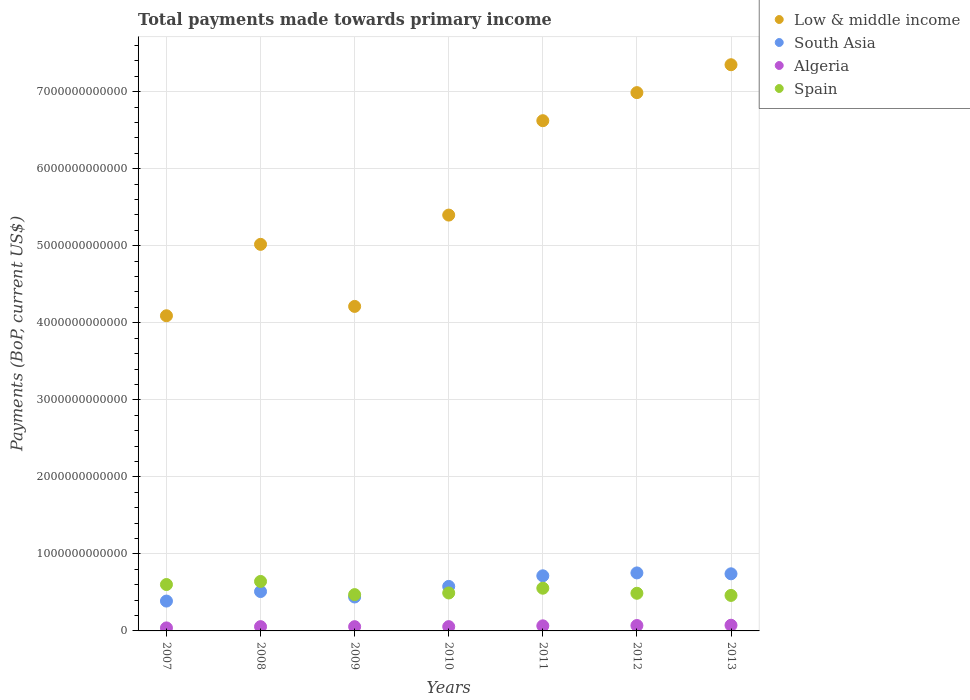What is the total payments made towards primary income in Spain in 2007?
Provide a succinct answer. 6.02e+11. Across all years, what is the maximum total payments made towards primary income in Low & middle income?
Your response must be concise. 7.35e+12. Across all years, what is the minimum total payments made towards primary income in Low & middle income?
Keep it short and to the point. 4.09e+12. In which year was the total payments made towards primary income in South Asia maximum?
Provide a succinct answer. 2012. What is the total total payments made towards primary income in Spain in the graph?
Provide a short and direct response. 3.71e+12. What is the difference between the total payments made towards primary income in Spain in 2009 and that in 2011?
Provide a short and direct response. -8.31e+1. What is the difference between the total payments made towards primary income in South Asia in 2011 and the total payments made towards primary income in Algeria in 2012?
Keep it short and to the point. 6.45e+11. What is the average total payments made towards primary income in Low & middle income per year?
Give a very brief answer. 5.67e+12. In the year 2011, what is the difference between the total payments made towards primary income in Spain and total payments made towards primary income in Low & middle income?
Keep it short and to the point. -6.07e+12. What is the ratio of the total payments made towards primary income in Low & middle income in 2008 to that in 2010?
Offer a very short reply. 0.93. Is the total payments made towards primary income in South Asia in 2007 less than that in 2013?
Keep it short and to the point. Yes. Is the difference between the total payments made towards primary income in Spain in 2007 and 2008 greater than the difference between the total payments made towards primary income in Low & middle income in 2007 and 2008?
Provide a short and direct response. Yes. What is the difference between the highest and the second highest total payments made towards primary income in South Asia?
Offer a very short reply. 1.15e+1. What is the difference between the highest and the lowest total payments made towards primary income in Low & middle income?
Make the answer very short. 3.26e+12. In how many years, is the total payments made towards primary income in Low & middle income greater than the average total payments made towards primary income in Low & middle income taken over all years?
Keep it short and to the point. 3. Is it the case that in every year, the sum of the total payments made towards primary income in Low & middle income and total payments made towards primary income in Algeria  is greater than the sum of total payments made towards primary income in Spain and total payments made towards primary income in South Asia?
Your answer should be compact. No. Is it the case that in every year, the sum of the total payments made towards primary income in Low & middle income and total payments made towards primary income in Spain  is greater than the total payments made towards primary income in South Asia?
Your answer should be very brief. Yes. Is the total payments made towards primary income in Spain strictly greater than the total payments made towards primary income in Algeria over the years?
Your answer should be compact. Yes. Is the total payments made towards primary income in Low & middle income strictly less than the total payments made towards primary income in Algeria over the years?
Keep it short and to the point. No. What is the difference between two consecutive major ticks on the Y-axis?
Provide a short and direct response. 1.00e+12. Does the graph contain grids?
Your answer should be compact. Yes. How are the legend labels stacked?
Your answer should be very brief. Vertical. What is the title of the graph?
Ensure brevity in your answer.  Total payments made towards primary income. What is the label or title of the X-axis?
Keep it short and to the point. Years. What is the label or title of the Y-axis?
Provide a short and direct response. Payments (BoP, current US$). What is the Payments (BoP, current US$) in Low & middle income in 2007?
Offer a terse response. 4.09e+12. What is the Payments (BoP, current US$) of South Asia in 2007?
Offer a terse response. 3.88e+11. What is the Payments (BoP, current US$) of Algeria in 2007?
Your response must be concise. 3.90e+1. What is the Payments (BoP, current US$) of Spain in 2007?
Your response must be concise. 6.02e+11. What is the Payments (BoP, current US$) of Low & middle income in 2008?
Give a very brief answer. 5.02e+12. What is the Payments (BoP, current US$) in South Asia in 2008?
Make the answer very short. 5.11e+11. What is the Payments (BoP, current US$) of Algeria in 2008?
Offer a very short reply. 5.54e+1. What is the Payments (BoP, current US$) in Spain in 2008?
Provide a short and direct response. 6.42e+11. What is the Payments (BoP, current US$) of Low & middle income in 2009?
Your response must be concise. 4.21e+12. What is the Payments (BoP, current US$) of South Asia in 2009?
Make the answer very short. 4.41e+11. What is the Payments (BoP, current US$) of Algeria in 2009?
Provide a short and direct response. 5.51e+1. What is the Payments (BoP, current US$) of Spain in 2009?
Your response must be concise. 4.71e+11. What is the Payments (BoP, current US$) of Low & middle income in 2010?
Ensure brevity in your answer.  5.40e+12. What is the Payments (BoP, current US$) in South Asia in 2010?
Ensure brevity in your answer.  5.78e+11. What is the Payments (BoP, current US$) of Algeria in 2010?
Ensure brevity in your answer.  5.56e+1. What is the Payments (BoP, current US$) of Spain in 2010?
Your answer should be very brief. 4.93e+11. What is the Payments (BoP, current US$) of Low & middle income in 2011?
Keep it short and to the point. 6.62e+12. What is the Payments (BoP, current US$) of South Asia in 2011?
Make the answer very short. 7.16e+11. What is the Payments (BoP, current US$) of Algeria in 2011?
Offer a very short reply. 6.60e+1. What is the Payments (BoP, current US$) of Spain in 2011?
Your answer should be very brief. 5.54e+11. What is the Payments (BoP, current US$) in Low & middle income in 2012?
Ensure brevity in your answer.  6.99e+12. What is the Payments (BoP, current US$) of South Asia in 2012?
Provide a short and direct response. 7.53e+11. What is the Payments (BoP, current US$) in Algeria in 2012?
Provide a succinct answer. 7.02e+1. What is the Payments (BoP, current US$) of Spain in 2012?
Your response must be concise. 4.89e+11. What is the Payments (BoP, current US$) in Low & middle income in 2013?
Offer a terse response. 7.35e+12. What is the Payments (BoP, current US$) of South Asia in 2013?
Make the answer very short. 7.41e+11. What is the Payments (BoP, current US$) of Algeria in 2013?
Your answer should be very brief. 7.37e+1. What is the Payments (BoP, current US$) of Spain in 2013?
Offer a very short reply. 4.61e+11. Across all years, what is the maximum Payments (BoP, current US$) of Low & middle income?
Your response must be concise. 7.35e+12. Across all years, what is the maximum Payments (BoP, current US$) of South Asia?
Your answer should be very brief. 7.53e+11. Across all years, what is the maximum Payments (BoP, current US$) in Algeria?
Offer a very short reply. 7.37e+1. Across all years, what is the maximum Payments (BoP, current US$) of Spain?
Make the answer very short. 6.42e+11. Across all years, what is the minimum Payments (BoP, current US$) of Low & middle income?
Offer a terse response. 4.09e+12. Across all years, what is the minimum Payments (BoP, current US$) of South Asia?
Give a very brief answer. 3.88e+11. Across all years, what is the minimum Payments (BoP, current US$) of Algeria?
Offer a very short reply. 3.90e+1. Across all years, what is the minimum Payments (BoP, current US$) of Spain?
Make the answer very short. 4.61e+11. What is the total Payments (BoP, current US$) of Low & middle income in the graph?
Keep it short and to the point. 3.97e+13. What is the total Payments (BoP, current US$) in South Asia in the graph?
Keep it short and to the point. 4.13e+12. What is the total Payments (BoP, current US$) of Algeria in the graph?
Keep it short and to the point. 4.15e+11. What is the total Payments (BoP, current US$) of Spain in the graph?
Your answer should be compact. 3.71e+12. What is the difference between the Payments (BoP, current US$) of Low & middle income in 2007 and that in 2008?
Make the answer very short. -9.27e+11. What is the difference between the Payments (BoP, current US$) in South Asia in 2007 and that in 2008?
Your answer should be very brief. -1.24e+11. What is the difference between the Payments (BoP, current US$) in Algeria in 2007 and that in 2008?
Provide a short and direct response. -1.64e+1. What is the difference between the Payments (BoP, current US$) in Spain in 2007 and that in 2008?
Your response must be concise. -3.99e+1. What is the difference between the Payments (BoP, current US$) of Low & middle income in 2007 and that in 2009?
Your answer should be very brief. -1.21e+11. What is the difference between the Payments (BoP, current US$) of South Asia in 2007 and that in 2009?
Make the answer very short. -5.31e+1. What is the difference between the Payments (BoP, current US$) of Algeria in 2007 and that in 2009?
Your answer should be compact. -1.61e+1. What is the difference between the Payments (BoP, current US$) of Spain in 2007 and that in 2009?
Make the answer very short. 1.31e+11. What is the difference between the Payments (BoP, current US$) in Low & middle income in 2007 and that in 2010?
Your answer should be compact. -1.31e+12. What is the difference between the Payments (BoP, current US$) of South Asia in 2007 and that in 2010?
Make the answer very short. -1.90e+11. What is the difference between the Payments (BoP, current US$) in Algeria in 2007 and that in 2010?
Ensure brevity in your answer.  -1.66e+1. What is the difference between the Payments (BoP, current US$) of Spain in 2007 and that in 2010?
Keep it short and to the point. 1.10e+11. What is the difference between the Payments (BoP, current US$) of Low & middle income in 2007 and that in 2011?
Make the answer very short. -2.53e+12. What is the difference between the Payments (BoP, current US$) of South Asia in 2007 and that in 2011?
Give a very brief answer. -3.28e+11. What is the difference between the Payments (BoP, current US$) in Algeria in 2007 and that in 2011?
Make the answer very short. -2.70e+1. What is the difference between the Payments (BoP, current US$) of Spain in 2007 and that in 2011?
Make the answer very short. 4.79e+1. What is the difference between the Payments (BoP, current US$) of Low & middle income in 2007 and that in 2012?
Give a very brief answer. -2.90e+12. What is the difference between the Payments (BoP, current US$) of South Asia in 2007 and that in 2012?
Provide a succinct answer. -3.65e+11. What is the difference between the Payments (BoP, current US$) of Algeria in 2007 and that in 2012?
Provide a succinct answer. -3.12e+1. What is the difference between the Payments (BoP, current US$) in Spain in 2007 and that in 2012?
Ensure brevity in your answer.  1.14e+11. What is the difference between the Payments (BoP, current US$) of Low & middle income in 2007 and that in 2013?
Keep it short and to the point. -3.26e+12. What is the difference between the Payments (BoP, current US$) in South Asia in 2007 and that in 2013?
Offer a terse response. -3.54e+11. What is the difference between the Payments (BoP, current US$) in Algeria in 2007 and that in 2013?
Offer a terse response. -3.47e+1. What is the difference between the Payments (BoP, current US$) in Spain in 2007 and that in 2013?
Ensure brevity in your answer.  1.41e+11. What is the difference between the Payments (BoP, current US$) of Low & middle income in 2008 and that in 2009?
Provide a succinct answer. 8.06e+11. What is the difference between the Payments (BoP, current US$) of South Asia in 2008 and that in 2009?
Provide a short and direct response. 7.06e+1. What is the difference between the Payments (BoP, current US$) in Algeria in 2008 and that in 2009?
Offer a very short reply. 2.97e+08. What is the difference between the Payments (BoP, current US$) of Spain in 2008 and that in 2009?
Your answer should be very brief. 1.71e+11. What is the difference between the Payments (BoP, current US$) of Low & middle income in 2008 and that in 2010?
Offer a very short reply. -3.80e+11. What is the difference between the Payments (BoP, current US$) of South Asia in 2008 and that in 2010?
Your answer should be compact. -6.66e+1. What is the difference between the Payments (BoP, current US$) in Algeria in 2008 and that in 2010?
Ensure brevity in your answer.  -2.06e+08. What is the difference between the Payments (BoP, current US$) in Spain in 2008 and that in 2010?
Offer a very short reply. 1.50e+11. What is the difference between the Payments (BoP, current US$) of Low & middle income in 2008 and that in 2011?
Make the answer very short. -1.61e+12. What is the difference between the Payments (BoP, current US$) in South Asia in 2008 and that in 2011?
Your answer should be compact. -2.04e+11. What is the difference between the Payments (BoP, current US$) of Algeria in 2008 and that in 2011?
Provide a succinct answer. -1.05e+1. What is the difference between the Payments (BoP, current US$) of Spain in 2008 and that in 2011?
Keep it short and to the point. 8.79e+1. What is the difference between the Payments (BoP, current US$) of Low & middle income in 2008 and that in 2012?
Provide a succinct answer. -1.97e+12. What is the difference between the Payments (BoP, current US$) of South Asia in 2008 and that in 2012?
Provide a short and direct response. -2.42e+11. What is the difference between the Payments (BoP, current US$) in Algeria in 2008 and that in 2012?
Your response must be concise. -1.47e+1. What is the difference between the Payments (BoP, current US$) of Spain in 2008 and that in 2012?
Provide a succinct answer. 1.54e+11. What is the difference between the Payments (BoP, current US$) in Low & middle income in 2008 and that in 2013?
Ensure brevity in your answer.  -2.33e+12. What is the difference between the Payments (BoP, current US$) of South Asia in 2008 and that in 2013?
Give a very brief answer. -2.30e+11. What is the difference between the Payments (BoP, current US$) of Algeria in 2008 and that in 2013?
Provide a short and direct response. -1.83e+1. What is the difference between the Payments (BoP, current US$) of Spain in 2008 and that in 2013?
Your answer should be compact. 1.81e+11. What is the difference between the Payments (BoP, current US$) in Low & middle income in 2009 and that in 2010?
Offer a terse response. -1.19e+12. What is the difference between the Payments (BoP, current US$) of South Asia in 2009 and that in 2010?
Ensure brevity in your answer.  -1.37e+11. What is the difference between the Payments (BoP, current US$) in Algeria in 2009 and that in 2010?
Provide a succinct answer. -5.04e+08. What is the difference between the Payments (BoP, current US$) of Spain in 2009 and that in 2010?
Keep it short and to the point. -2.13e+1. What is the difference between the Payments (BoP, current US$) in Low & middle income in 2009 and that in 2011?
Make the answer very short. -2.41e+12. What is the difference between the Payments (BoP, current US$) of South Asia in 2009 and that in 2011?
Your response must be concise. -2.75e+11. What is the difference between the Payments (BoP, current US$) in Algeria in 2009 and that in 2011?
Your response must be concise. -1.08e+1. What is the difference between the Payments (BoP, current US$) in Spain in 2009 and that in 2011?
Offer a very short reply. -8.31e+1. What is the difference between the Payments (BoP, current US$) in Low & middle income in 2009 and that in 2012?
Provide a short and direct response. -2.78e+12. What is the difference between the Payments (BoP, current US$) of South Asia in 2009 and that in 2012?
Offer a terse response. -3.12e+11. What is the difference between the Payments (BoP, current US$) of Algeria in 2009 and that in 2012?
Provide a short and direct response. -1.50e+1. What is the difference between the Payments (BoP, current US$) of Spain in 2009 and that in 2012?
Give a very brief answer. -1.75e+1. What is the difference between the Payments (BoP, current US$) in Low & middle income in 2009 and that in 2013?
Offer a terse response. -3.14e+12. What is the difference between the Payments (BoP, current US$) in South Asia in 2009 and that in 2013?
Provide a short and direct response. -3.01e+11. What is the difference between the Payments (BoP, current US$) in Algeria in 2009 and that in 2013?
Offer a terse response. -1.86e+1. What is the difference between the Payments (BoP, current US$) of Spain in 2009 and that in 2013?
Your answer should be very brief. 1.04e+1. What is the difference between the Payments (BoP, current US$) in Low & middle income in 2010 and that in 2011?
Your answer should be very brief. -1.23e+12. What is the difference between the Payments (BoP, current US$) of South Asia in 2010 and that in 2011?
Give a very brief answer. -1.38e+11. What is the difference between the Payments (BoP, current US$) in Algeria in 2010 and that in 2011?
Offer a very short reply. -1.03e+1. What is the difference between the Payments (BoP, current US$) in Spain in 2010 and that in 2011?
Make the answer very short. -6.18e+1. What is the difference between the Payments (BoP, current US$) in Low & middle income in 2010 and that in 2012?
Offer a terse response. -1.59e+12. What is the difference between the Payments (BoP, current US$) in South Asia in 2010 and that in 2012?
Your answer should be compact. -1.75e+11. What is the difference between the Payments (BoP, current US$) in Algeria in 2010 and that in 2012?
Your answer should be compact. -1.45e+1. What is the difference between the Payments (BoP, current US$) in Spain in 2010 and that in 2012?
Make the answer very short. 3.82e+09. What is the difference between the Payments (BoP, current US$) in Low & middle income in 2010 and that in 2013?
Ensure brevity in your answer.  -1.95e+12. What is the difference between the Payments (BoP, current US$) of South Asia in 2010 and that in 2013?
Give a very brief answer. -1.64e+11. What is the difference between the Payments (BoP, current US$) in Algeria in 2010 and that in 2013?
Provide a succinct answer. -1.81e+1. What is the difference between the Payments (BoP, current US$) in Spain in 2010 and that in 2013?
Provide a succinct answer. 3.17e+1. What is the difference between the Payments (BoP, current US$) in Low & middle income in 2011 and that in 2012?
Offer a very short reply. -3.64e+11. What is the difference between the Payments (BoP, current US$) in South Asia in 2011 and that in 2012?
Provide a succinct answer. -3.74e+1. What is the difference between the Payments (BoP, current US$) of Algeria in 2011 and that in 2012?
Offer a very short reply. -4.19e+09. What is the difference between the Payments (BoP, current US$) of Spain in 2011 and that in 2012?
Your answer should be very brief. 6.56e+1. What is the difference between the Payments (BoP, current US$) in Low & middle income in 2011 and that in 2013?
Provide a short and direct response. -7.26e+11. What is the difference between the Payments (BoP, current US$) of South Asia in 2011 and that in 2013?
Your answer should be very brief. -2.58e+1. What is the difference between the Payments (BoP, current US$) of Algeria in 2011 and that in 2013?
Your response must be concise. -7.75e+09. What is the difference between the Payments (BoP, current US$) of Spain in 2011 and that in 2013?
Keep it short and to the point. 9.35e+1. What is the difference between the Payments (BoP, current US$) in Low & middle income in 2012 and that in 2013?
Your answer should be very brief. -3.62e+11. What is the difference between the Payments (BoP, current US$) of South Asia in 2012 and that in 2013?
Give a very brief answer. 1.15e+1. What is the difference between the Payments (BoP, current US$) of Algeria in 2012 and that in 2013?
Provide a short and direct response. -3.55e+09. What is the difference between the Payments (BoP, current US$) of Spain in 2012 and that in 2013?
Make the answer very short. 2.79e+1. What is the difference between the Payments (BoP, current US$) in Low & middle income in 2007 and the Payments (BoP, current US$) in South Asia in 2008?
Give a very brief answer. 3.58e+12. What is the difference between the Payments (BoP, current US$) of Low & middle income in 2007 and the Payments (BoP, current US$) of Algeria in 2008?
Keep it short and to the point. 4.04e+12. What is the difference between the Payments (BoP, current US$) of Low & middle income in 2007 and the Payments (BoP, current US$) of Spain in 2008?
Provide a short and direct response. 3.45e+12. What is the difference between the Payments (BoP, current US$) in South Asia in 2007 and the Payments (BoP, current US$) in Algeria in 2008?
Your answer should be compact. 3.32e+11. What is the difference between the Payments (BoP, current US$) of South Asia in 2007 and the Payments (BoP, current US$) of Spain in 2008?
Provide a short and direct response. -2.55e+11. What is the difference between the Payments (BoP, current US$) of Algeria in 2007 and the Payments (BoP, current US$) of Spain in 2008?
Keep it short and to the point. -6.03e+11. What is the difference between the Payments (BoP, current US$) of Low & middle income in 2007 and the Payments (BoP, current US$) of South Asia in 2009?
Your answer should be compact. 3.65e+12. What is the difference between the Payments (BoP, current US$) of Low & middle income in 2007 and the Payments (BoP, current US$) of Algeria in 2009?
Offer a terse response. 4.04e+12. What is the difference between the Payments (BoP, current US$) in Low & middle income in 2007 and the Payments (BoP, current US$) in Spain in 2009?
Keep it short and to the point. 3.62e+12. What is the difference between the Payments (BoP, current US$) in South Asia in 2007 and the Payments (BoP, current US$) in Algeria in 2009?
Provide a short and direct response. 3.32e+11. What is the difference between the Payments (BoP, current US$) of South Asia in 2007 and the Payments (BoP, current US$) of Spain in 2009?
Provide a short and direct response. -8.37e+1. What is the difference between the Payments (BoP, current US$) in Algeria in 2007 and the Payments (BoP, current US$) in Spain in 2009?
Your answer should be very brief. -4.32e+11. What is the difference between the Payments (BoP, current US$) in Low & middle income in 2007 and the Payments (BoP, current US$) in South Asia in 2010?
Your answer should be compact. 3.51e+12. What is the difference between the Payments (BoP, current US$) in Low & middle income in 2007 and the Payments (BoP, current US$) in Algeria in 2010?
Provide a short and direct response. 4.04e+12. What is the difference between the Payments (BoP, current US$) in Low & middle income in 2007 and the Payments (BoP, current US$) in Spain in 2010?
Provide a succinct answer. 3.60e+12. What is the difference between the Payments (BoP, current US$) in South Asia in 2007 and the Payments (BoP, current US$) in Algeria in 2010?
Offer a terse response. 3.32e+11. What is the difference between the Payments (BoP, current US$) in South Asia in 2007 and the Payments (BoP, current US$) in Spain in 2010?
Offer a very short reply. -1.05e+11. What is the difference between the Payments (BoP, current US$) of Algeria in 2007 and the Payments (BoP, current US$) of Spain in 2010?
Give a very brief answer. -4.54e+11. What is the difference between the Payments (BoP, current US$) in Low & middle income in 2007 and the Payments (BoP, current US$) in South Asia in 2011?
Your answer should be compact. 3.38e+12. What is the difference between the Payments (BoP, current US$) of Low & middle income in 2007 and the Payments (BoP, current US$) of Algeria in 2011?
Ensure brevity in your answer.  4.03e+12. What is the difference between the Payments (BoP, current US$) of Low & middle income in 2007 and the Payments (BoP, current US$) of Spain in 2011?
Your answer should be very brief. 3.54e+12. What is the difference between the Payments (BoP, current US$) in South Asia in 2007 and the Payments (BoP, current US$) in Algeria in 2011?
Give a very brief answer. 3.22e+11. What is the difference between the Payments (BoP, current US$) in South Asia in 2007 and the Payments (BoP, current US$) in Spain in 2011?
Provide a short and direct response. -1.67e+11. What is the difference between the Payments (BoP, current US$) of Algeria in 2007 and the Payments (BoP, current US$) of Spain in 2011?
Ensure brevity in your answer.  -5.15e+11. What is the difference between the Payments (BoP, current US$) of Low & middle income in 2007 and the Payments (BoP, current US$) of South Asia in 2012?
Provide a succinct answer. 3.34e+12. What is the difference between the Payments (BoP, current US$) of Low & middle income in 2007 and the Payments (BoP, current US$) of Algeria in 2012?
Provide a short and direct response. 4.02e+12. What is the difference between the Payments (BoP, current US$) in Low & middle income in 2007 and the Payments (BoP, current US$) in Spain in 2012?
Your answer should be very brief. 3.60e+12. What is the difference between the Payments (BoP, current US$) in South Asia in 2007 and the Payments (BoP, current US$) in Algeria in 2012?
Offer a very short reply. 3.17e+11. What is the difference between the Payments (BoP, current US$) of South Asia in 2007 and the Payments (BoP, current US$) of Spain in 2012?
Your answer should be compact. -1.01e+11. What is the difference between the Payments (BoP, current US$) of Algeria in 2007 and the Payments (BoP, current US$) of Spain in 2012?
Give a very brief answer. -4.50e+11. What is the difference between the Payments (BoP, current US$) of Low & middle income in 2007 and the Payments (BoP, current US$) of South Asia in 2013?
Keep it short and to the point. 3.35e+12. What is the difference between the Payments (BoP, current US$) of Low & middle income in 2007 and the Payments (BoP, current US$) of Algeria in 2013?
Keep it short and to the point. 4.02e+12. What is the difference between the Payments (BoP, current US$) in Low & middle income in 2007 and the Payments (BoP, current US$) in Spain in 2013?
Your answer should be very brief. 3.63e+12. What is the difference between the Payments (BoP, current US$) in South Asia in 2007 and the Payments (BoP, current US$) in Algeria in 2013?
Provide a succinct answer. 3.14e+11. What is the difference between the Payments (BoP, current US$) in South Asia in 2007 and the Payments (BoP, current US$) in Spain in 2013?
Your response must be concise. -7.34e+1. What is the difference between the Payments (BoP, current US$) in Algeria in 2007 and the Payments (BoP, current US$) in Spain in 2013?
Your answer should be compact. -4.22e+11. What is the difference between the Payments (BoP, current US$) of Low & middle income in 2008 and the Payments (BoP, current US$) of South Asia in 2009?
Ensure brevity in your answer.  4.58e+12. What is the difference between the Payments (BoP, current US$) in Low & middle income in 2008 and the Payments (BoP, current US$) in Algeria in 2009?
Ensure brevity in your answer.  4.96e+12. What is the difference between the Payments (BoP, current US$) in Low & middle income in 2008 and the Payments (BoP, current US$) in Spain in 2009?
Your answer should be very brief. 4.55e+12. What is the difference between the Payments (BoP, current US$) in South Asia in 2008 and the Payments (BoP, current US$) in Algeria in 2009?
Offer a very short reply. 4.56e+11. What is the difference between the Payments (BoP, current US$) of South Asia in 2008 and the Payments (BoP, current US$) of Spain in 2009?
Your response must be concise. 3.99e+1. What is the difference between the Payments (BoP, current US$) of Algeria in 2008 and the Payments (BoP, current US$) of Spain in 2009?
Offer a very short reply. -4.16e+11. What is the difference between the Payments (BoP, current US$) in Low & middle income in 2008 and the Payments (BoP, current US$) in South Asia in 2010?
Your answer should be very brief. 4.44e+12. What is the difference between the Payments (BoP, current US$) of Low & middle income in 2008 and the Payments (BoP, current US$) of Algeria in 2010?
Offer a very short reply. 4.96e+12. What is the difference between the Payments (BoP, current US$) in Low & middle income in 2008 and the Payments (BoP, current US$) in Spain in 2010?
Make the answer very short. 4.53e+12. What is the difference between the Payments (BoP, current US$) in South Asia in 2008 and the Payments (BoP, current US$) in Algeria in 2010?
Keep it short and to the point. 4.56e+11. What is the difference between the Payments (BoP, current US$) in South Asia in 2008 and the Payments (BoP, current US$) in Spain in 2010?
Make the answer very short. 1.86e+1. What is the difference between the Payments (BoP, current US$) of Algeria in 2008 and the Payments (BoP, current US$) of Spain in 2010?
Give a very brief answer. -4.37e+11. What is the difference between the Payments (BoP, current US$) of Low & middle income in 2008 and the Payments (BoP, current US$) of South Asia in 2011?
Provide a succinct answer. 4.30e+12. What is the difference between the Payments (BoP, current US$) of Low & middle income in 2008 and the Payments (BoP, current US$) of Algeria in 2011?
Provide a succinct answer. 4.95e+12. What is the difference between the Payments (BoP, current US$) of Low & middle income in 2008 and the Payments (BoP, current US$) of Spain in 2011?
Offer a very short reply. 4.46e+12. What is the difference between the Payments (BoP, current US$) in South Asia in 2008 and the Payments (BoP, current US$) in Algeria in 2011?
Provide a succinct answer. 4.45e+11. What is the difference between the Payments (BoP, current US$) of South Asia in 2008 and the Payments (BoP, current US$) of Spain in 2011?
Provide a succinct answer. -4.32e+1. What is the difference between the Payments (BoP, current US$) in Algeria in 2008 and the Payments (BoP, current US$) in Spain in 2011?
Provide a short and direct response. -4.99e+11. What is the difference between the Payments (BoP, current US$) of Low & middle income in 2008 and the Payments (BoP, current US$) of South Asia in 2012?
Offer a terse response. 4.27e+12. What is the difference between the Payments (BoP, current US$) of Low & middle income in 2008 and the Payments (BoP, current US$) of Algeria in 2012?
Give a very brief answer. 4.95e+12. What is the difference between the Payments (BoP, current US$) of Low & middle income in 2008 and the Payments (BoP, current US$) of Spain in 2012?
Provide a succinct answer. 4.53e+12. What is the difference between the Payments (BoP, current US$) of South Asia in 2008 and the Payments (BoP, current US$) of Algeria in 2012?
Offer a very short reply. 4.41e+11. What is the difference between the Payments (BoP, current US$) in South Asia in 2008 and the Payments (BoP, current US$) in Spain in 2012?
Provide a short and direct response. 2.24e+1. What is the difference between the Payments (BoP, current US$) of Algeria in 2008 and the Payments (BoP, current US$) of Spain in 2012?
Make the answer very short. -4.33e+11. What is the difference between the Payments (BoP, current US$) of Low & middle income in 2008 and the Payments (BoP, current US$) of South Asia in 2013?
Offer a terse response. 4.28e+12. What is the difference between the Payments (BoP, current US$) in Low & middle income in 2008 and the Payments (BoP, current US$) in Algeria in 2013?
Offer a very short reply. 4.94e+12. What is the difference between the Payments (BoP, current US$) in Low & middle income in 2008 and the Payments (BoP, current US$) in Spain in 2013?
Provide a short and direct response. 4.56e+12. What is the difference between the Payments (BoP, current US$) of South Asia in 2008 and the Payments (BoP, current US$) of Algeria in 2013?
Ensure brevity in your answer.  4.38e+11. What is the difference between the Payments (BoP, current US$) in South Asia in 2008 and the Payments (BoP, current US$) in Spain in 2013?
Give a very brief answer. 5.03e+1. What is the difference between the Payments (BoP, current US$) of Algeria in 2008 and the Payments (BoP, current US$) of Spain in 2013?
Your answer should be very brief. -4.05e+11. What is the difference between the Payments (BoP, current US$) in Low & middle income in 2009 and the Payments (BoP, current US$) in South Asia in 2010?
Your answer should be very brief. 3.63e+12. What is the difference between the Payments (BoP, current US$) of Low & middle income in 2009 and the Payments (BoP, current US$) of Algeria in 2010?
Your response must be concise. 4.16e+12. What is the difference between the Payments (BoP, current US$) of Low & middle income in 2009 and the Payments (BoP, current US$) of Spain in 2010?
Provide a succinct answer. 3.72e+12. What is the difference between the Payments (BoP, current US$) in South Asia in 2009 and the Payments (BoP, current US$) in Algeria in 2010?
Keep it short and to the point. 3.85e+11. What is the difference between the Payments (BoP, current US$) in South Asia in 2009 and the Payments (BoP, current US$) in Spain in 2010?
Your answer should be compact. -5.20e+1. What is the difference between the Payments (BoP, current US$) in Algeria in 2009 and the Payments (BoP, current US$) in Spain in 2010?
Make the answer very short. -4.37e+11. What is the difference between the Payments (BoP, current US$) of Low & middle income in 2009 and the Payments (BoP, current US$) of South Asia in 2011?
Provide a succinct answer. 3.50e+12. What is the difference between the Payments (BoP, current US$) in Low & middle income in 2009 and the Payments (BoP, current US$) in Algeria in 2011?
Your answer should be very brief. 4.15e+12. What is the difference between the Payments (BoP, current US$) of Low & middle income in 2009 and the Payments (BoP, current US$) of Spain in 2011?
Make the answer very short. 3.66e+12. What is the difference between the Payments (BoP, current US$) in South Asia in 2009 and the Payments (BoP, current US$) in Algeria in 2011?
Give a very brief answer. 3.75e+11. What is the difference between the Payments (BoP, current US$) in South Asia in 2009 and the Payments (BoP, current US$) in Spain in 2011?
Ensure brevity in your answer.  -1.14e+11. What is the difference between the Payments (BoP, current US$) of Algeria in 2009 and the Payments (BoP, current US$) of Spain in 2011?
Your answer should be very brief. -4.99e+11. What is the difference between the Payments (BoP, current US$) of Low & middle income in 2009 and the Payments (BoP, current US$) of South Asia in 2012?
Make the answer very short. 3.46e+12. What is the difference between the Payments (BoP, current US$) in Low & middle income in 2009 and the Payments (BoP, current US$) in Algeria in 2012?
Make the answer very short. 4.14e+12. What is the difference between the Payments (BoP, current US$) of Low & middle income in 2009 and the Payments (BoP, current US$) of Spain in 2012?
Provide a short and direct response. 3.72e+12. What is the difference between the Payments (BoP, current US$) in South Asia in 2009 and the Payments (BoP, current US$) in Algeria in 2012?
Ensure brevity in your answer.  3.70e+11. What is the difference between the Payments (BoP, current US$) in South Asia in 2009 and the Payments (BoP, current US$) in Spain in 2012?
Your answer should be compact. -4.82e+1. What is the difference between the Payments (BoP, current US$) in Algeria in 2009 and the Payments (BoP, current US$) in Spain in 2012?
Provide a succinct answer. -4.34e+11. What is the difference between the Payments (BoP, current US$) of Low & middle income in 2009 and the Payments (BoP, current US$) of South Asia in 2013?
Your answer should be compact. 3.47e+12. What is the difference between the Payments (BoP, current US$) of Low & middle income in 2009 and the Payments (BoP, current US$) of Algeria in 2013?
Your response must be concise. 4.14e+12. What is the difference between the Payments (BoP, current US$) in Low & middle income in 2009 and the Payments (BoP, current US$) in Spain in 2013?
Your answer should be compact. 3.75e+12. What is the difference between the Payments (BoP, current US$) in South Asia in 2009 and the Payments (BoP, current US$) in Algeria in 2013?
Make the answer very short. 3.67e+11. What is the difference between the Payments (BoP, current US$) of South Asia in 2009 and the Payments (BoP, current US$) of Spain in 2013?
Make the answer very short. -2.03e+1. What is the difference between the Payments (BoP, current US$) of Algeria in 2009 and the Payments (BoP, current US$) of Spain in 2013?
Offer a very short reply. -4.06e+11. What is the difference between the Payments (BoP, current US$) of Low & middle income in 2010 and the Payments (BoP, current US$) of South Asia in 2011?
Provide a short and direct response. 4.68e+12. What is the difference between the Payments (BoP, current US$) in Low & middle income in 2010 and the Payments (BoP, current US$) in Algeria in 2011?
Provide a short and direct response. 5.33e+12. What is the difference between the Payments (BoP, current US$) in Low & middle income in 2010 and the Payments (BoP, current US$) in Spain in 2011?
Give a very brief answer. 4.84e+12. What is the difference between the Payments (BoP, current US$) in South Asia in 2010 and the Payments (BoP, current US$) in Algeria in 2011?
Make the answer very short. 5.12e+11. What is the difference between the Payments (BoP, current US$) of South Asia in 2010 and the Payments (BoP, current US$) of Spain in 2011?
Ensure brevity in your answer.  2.34e+1. What is the difference between the Payments (BoP, current US$) in Algeria in 2010 and the Payments (BoP, current US$) in Spain in 2011?
Offer a very short reply. -4.99e+11. What is the difference between the Payments (BoP, current US$) of Low & middle income in 2010 and the Payments (BoP, current US$) of South Asia in 2012?
Your answer should be very brief. 4.65e+12. What is the difference between the Payments (BoP, current US$) in Low & middle income in 2010 and the Payments (BoP, current US$) in Algeria in 2012?
Give a very brief answer. 5.33e+12. What is the difference between the Payments (BoP, current US$) in Low & middle income in 2010 and the Payments (BoP, current US$) in Spain in 2012?
Make the answer very short. 4.91e+12. What is the difference between the Payments (BoP, current US$) of South Asia in 2010 and the Payments (BoP, current US$) of Algeria in 2012?
Your answer should be compact. 5.08e+11. What is the difference between the Payments (BoP, current US$) in South Asia in 2010 and the Payments (BoP, current US$) in Spain in 2012?
Make the answer very short. 8.91e+1. What is the difference between the Payments (BoP, current US$) of Algeria in 2010 and the Payments (BoP, current US$) of Spain in 2012?
Provide a succinct answer. -4.33e+11. What is the difference between the Payments (BoP, current US$) of Low & middle income in 2010 and the Payments (BoP, current US$) of South Asia in 2013?
Offer a terse response. 4.66e+12. What is the difference between the Payments (BoP, current US$) in Low & middle income in 2010 and the Payments (BoP, current US$) in Algeria in 2013?
Your answer should be very brief. 5.32e+12. What is the difference between the Payments (BoP, current US$) in Low & middle income in 2010 and the Payments (BoP, current US$) in Spain in 2013?
Your response must be concise. 4.94e+12. What is the difference between the Payments (BoP, current US$) of South Asia in 2010 and the Payments (BoP, current US$) of Algeria in 2013?
Keep it short and to the point. 5.04e+11. What is the difference between the Payments (BoP, current US$) in South Asia in 2010 and the Payments (BoP, current US$) in Spain in 2013?
Keep it short and to the point. 1.17e+11. What is the difference between the Payments (BoP, current US$) in Algeria in 2010 and the Payments (BoP, current US$) in Spain in 2013?
Make the answer very short. -4.05e+11. What is the difference between the Payments (BoP, current US$) in Low & middle income in 2011 and the Payments (BoP, current US$) in South Asia in 2012?
Offer a very short reply. 5.87e+12. What is the difference between the Payments (BoP, current US$) in Low & middle income in 2011 and the Payments (BoP, current US$) in Algeria in 2012?
Ensure brevity in your answer.  6.55e+12. What is the difference between the Payments (BoP, current US$) of Low & middle income in 2011 and the Payments (BoP, current US$) of Spain in 2012?
Your answer should be compact. 6.13e+12. What is the difference between the Payments (BoP, current US$) in South Asia in 2011 and the Payments (BoP, current US$) in Algeria in 2012?
Keep it short and to the point. 6.45e+11. What is the difference between the Payments (BoP, current US$) in South Asia in 2011 and the Payments (BoP, current US$) in Spain in 2012?
Ensure brevity in your answer.  2.27e+11. What is the difference between the Payments (BoP, current US$) of Algeria in 2011 and the Payments (BoP, current US$) of Spain in 2012?
Your answer should be compact. -4.23e+11. What is the difference between the Payments (BoP, current US$) of Low & middle income in 2011 and the Payments (BoP, current US$) of South Asia in 2013?
Provide a short and direct response. 5.88e+12. What is the difference between the Payments (BoP, current US$) in Low & middle income in 2011 and the Payments (BoP, current US$) in Algeria in 2013?
Provide a succinct answer. 6.55e+12. What is the difference between the Payments (BoP, current US$) in Low & middle income in 2011 and the Payments (BoP, current US$) in Spain in 2013?
Ensure brevity in your answer.  6.16e+12. What is the difference between the Payments (BoP, current US$) of South Asia in 2011 and the Payments (BoP, current US$) of Algeria in 2013?
Offer a very short reply. 6.42e+11. What is the difference between the Payments (BoP, current US$) in South Asia in 2011 and the Payments (BoP, current US$) in Spain in 2013?
Offer a terse response. 2.55e+11. What is the difference between the Payments (BoP, current US$) of Algeria in 2011 and the Payments (BoP, current US$) of Spain in 2013?
Provide a short and direct response. -3.95e+11. What is the difference between the Payments (BoP, current US$) of Low & middle income in 2012 and the Payments (BoP, current US$) of South Asia in 2013?
Your response must be concise. 6.25e+12. What is the difference between the Payments (BoP, current US$) of Low & middle income in 2012 and the Payments (BoP, current US$) of Algeria in 2013?
Your answer should be very brief. 6.91e+12. What is the difference between the Payments (BoP, current US$) in Low & middle income in 2012 and the Payments (BoP, current US$) in Spain in 2013?
Offer a terse response. 6.53e+12. What is the difference between the Payments (BoP, current US$) in South Asia in 2012 and the Payments (BoP, current US$) in Algeria in 2013?
Provide a succinct answer. 6.79e+11. What is the difference between the Payments (BoP, current US$) of South Asia in 2012 and the Payments (BoP, current US$) of Spain in 2013?
Provide a succinct answer. 2.92e+11. What is the difference between the Payments (BoP, current US$) of Algeria in 2012 and the Payments (BoP, current US$) of Spain in 2013?
Keep it short and to the point. -3.91e+11. What is the average Payments (BoP, current US$) of Low & middle income per year?
Ensure brevity in your answer.  5.67e+12. What is the average Payments (BoP, current US$) in South Asia per year?
Your response must be concise. 5.90e+11. What is the average Payments (BoP, current US$) of Algeria per year?
Make the answer very short. 5.93e+1. What is the average Payments (BoP, current US$) in Spain per year?
Give a very brief answer. 5.30e+11. In the year 2007, what is the difference between the Payments (BoP, current US$) in Low & middle income and Payments (BoP, current US$) in South Asia?
Make the answer very short. 3.70e+12. In the year 2007, what is the difference between the Payments (BoP, current US$) in Low & middle income and Payments (BoP, current US$) in Algeria?
Make the answer very short. 4.05e+12. In the year 2007, what is the difference between the Payments (BoP, current US$) in Low & middle income and Payments (BoP, current US$) in Spain?
Offer a very short reply. 3.49e+12. In the year 2007, what is the difference between the Payments (BoP, current US$) of South Asia and Payments (BoP, current US$) of Algeria?
Ensure brevity in your answer.  3.49e+11. In the year 2007, what is the difference between the Payments (BoP, current US$) of South Asia and Payments (BoP, current US$) of Spain?
Keep it short and to the point. -2.15e+11. In the year 2007, what is the difference between the Payments (BoP, current US$) in Algeria and Payments (BoP, current US$) in Spain?
Your response must be concise. -5.63e+11. In the year 2008, what is the difference between the Payments (BoP, current US$) of Low & middle income and Payments (BoP, current US$) of South Asia?
Your answer should be very brief. 4.51e+12. In the year 2008, what is the difference between the Payments (BoP, current US$) of Low & middle income and Payments (BoP, current US$) of Algeria?
Ensure brevity in your answer.  4.96e+12. In the year 2008, what is the difference between the Payments (BoP, current US$) in Low & middle income and Payments (BoP, current US$) in Spain?
Provide a short and direct response. 4.38e+12. In the year 2008, what is the difference between the Payments (BoP, current US$) of South Asia and Payments (BoP, current US$) of Algeria?
Provide a succinct answer. 4.56e+11. In the year 2008, what is the difference between the Payments (BoP, current US$) in South Asia and Payments (BoP, current US$) in Spain?
Offer a very short reply. -1.31e+11. In the year 2008, what is the difference between the Payments (BoP, current US$) of Algeria and Payments (BoP, current US$) of Spain?
Give a very brief answer. -5.87e+11. In the year 2009, what is the difference between the Payments (BoP, current US$) in Low & middle income and Payments (BoP, current US$) in South Asia?
Make the answer very short. 3.77e+12. In the year 2009, what is the difference between the Payments (BoP, current US$) of Low & middle income and Payments (BoP, current US$) of Algeria?
Offer a terse response. 4.16e+12. In the year 2009, what is the difference between the Payments (BoP, current US$) of Low & middle income and Payments (BoP, current US$) of Spain?
Offer a terse response. 3.74e+12. In the year 2009, what is the difference between the Payments (BoP, current US$) in South Asia and Payments (BoP, current US$) in Algeria?
Provide a succinct answer. 3.86e+11. In the year 2009, what is the difference between the Payments (BoP, current US$) of South Asia and Payments (BoP, current US$) of Spain?
Provide a succinct answer. -3.07e+1. In the year 2009, what is the difference between the Payments (BoP, current US$) of Algeria and Payments (BoP, current US$) of Spain?
Provide a succinct answer. -4.16e+11. In the year 2010, what is the difference between the Payments (BoP, current US$) in Low & middle income and Payments (BoP, current US$) in South Asia?
Keep it short and to the point. 4.82e+12. In the year 2010, what is the difference between the Payments (BoP, current US$) of Low & middle income and Payments (BoP, current US$) of Algeria?
Keep it short and to the point. 5.34e+12. In the year 2010, what is the difference between the Payments (BoP, current US$) in Low & middle income and Payments (BoP, current US$) in Spain?
Provide a succinct answer. 4.91e+12. In the year 2010, what is the difference between the Payments (BoP, current US$) in South Asia and Payments (BoP, current US$) in Algeria?
Keep it short and to the point. 5.22e+11. In the year 2010, what is the difference between the Payments (BoP, current US$) of South Asia and Payments (BoP, current US$) of Spain?
Offer a very short reply. 8.53e+1. In the year 2010, what is the difference between the Payments (BoP, current US$) in Algeria and Payments (BoP, current US$) in Spain?
Your response must be concise. -4.37e+11. In the year 2011, what is the difference between the Payments (BoP, current US$) of Low & middle income and Payments (BoP, current US$) of South Asia?
Your response must be concise. 5.91e+12. In the year 2011, what is the difference between the Payments (BoP, current US$) in Low & middle income and Payments (BoP, current US$) in Algeria?
Your response must be concise. 6.56e+12. In the year 2011, what is the difference between the Payments (BoP, current US$) in Low & middle income and Payments (BoP, current US$) in Spain?
Offer a terse response. 6.07e+12. In the year 2011, what is the difference between the Payments (BoP, current US$) in South Asia and Payments (BoP, current US$) in Algeria?
Offer a terse response. 6.50e+11. In the year 2011, what is the difference between the Payments (BoP, current US$) in South Asia and Payments (BoP, current US$) in Spain?
Offer a terse response. 1.61e+11. In the year 2011, what is the difference between the Payments (BoP, current US$) in Algeria and Payments (BoP, current US$) in Spain?
Offer a very short reply. -4.88e+11. In the year 2012, what is the difference between the Payments (BoP, current US$) of Low & middle income and Payments (BoP, current US$) of South Asia?
Your response must be concise. 6.23e+12. In the year 2012, what is the difference between the Payments (BoP, current US$) in Low & middle income and Payments (BoP, current US$) in Algeria?
Make the answer very short. 6.92e+12. In the year 2012, what is the difference between the Payments (BoP, current US$) of Low & middle income and Payments (BoP, current US$) of Spain?
Give a very brief answer. 6.50e+12. In the year 2012, what is the difference between the Payments (BoP, current US$) of South Asia and Payments (BoP, current US$) of Algeria?
Your answer should be compact. 6.83e+11. In the year 2012, what is the difference between the Payments (BoP, current US$) in South Asia and Payments (BoP, current US$) in Spain?
Offer a very short reply. 2.64e+11. In the year 2012, what is the difference between the Payments (BoP, current US$) in Algeria and Payments (BoP, current US$) in Spain?
Make the answer very short. -4.19e+11. In the year 2013, what is the difference between the Payments (BoP, current US$) in Low & middle income and Payments (BoP, current US$) in South Asia?
Keep it short and to the point. 6.61e+12. In the year 2013, what is the difference between the Payments (BoP, current US$) of Low & middle income and Payments (BoP, current US$) of Algeria?
Offer a terse response. 7.28e+12. In the year 2013, what is the difference between the Payments (BoP, current US$) in Low & middle income and Payments (BoP, current US$) in Spain?
Make the answer very short. 6.89e+12. In the year 2013, what is the difference between the Payments (BoP, current US$) of South Asia and Payments (BoP, current US$) of Algeria?
Give a very brief answer. 6.68e+11. In the year 2013, what is the difference between the Payments (BoP, current US$) in South Asia and Payments (BoP, current US$) in Spain?
Make the answer very short. 2.81e+11. In the year 2013, what is the difference between the Payments (BoP, current US$) in Algeria and Payments (BoP, current US$) in Spain?
Your answer should be compact. -3.87e+11. What is the ratio of the Payments (BoP, current US$) of Low & middle income in 2007 to that in 2008?
Offer a terse response. 0.82. What is the ratio of the Payments (BoP, current US$) in South Asia in 2007 to that in 2008?
Provide a short and direct response. 0.76. What is the ratio of the Payments (BoP, current US$) in Algeria in 2007 to that in 2008?
Your answer should be very brief. 0.7. What is the ratio of the Payments (BoP, current US$) in Spain in 2007 to that in 2008?
Offer a very short reply. 0.94. What is the ratio of the Payments (BoP, current US$) of Low & middle income in 2007 to that in 2009?
Ensure brevity in your answer.  0.97. What is the ratio of the Payments (BoP, current US$) in South Asia in 2007 to that in 2009?
Make the answer very short. 0.88. What is the ratio of the Payments (BoP, current US$) of Algeria in 2007 to that in 2009?
Ensure brevity in your answer.  0.71. What is the ratio of the Payments (BoP, current US$) of Spain in 2007 to that in 2009?
Your response must be concise. 1.28. What is the ratio of the Payments (BoP, current US$) of Low & middle income in 2007 to that in 2010?
Provide a short and direct response. 0.76. What is the ratio of the Payments (BoP, current US$) in South Asia in 2007 to that in 2010?
Give a very brief answer. 0.67. What is the ratio of the Payments (BoP, current US$) of Algeria in 2007 to that in 2010?
Offer a terse response. 0.7. What is the ratio of the Payments (BoP, current US$) of Spain in 2007 to that in 2010?
Make the answer very short. 1.22. What is the ratio of the Payments (BoP, current US$) of Low & middle income in 2007 to that in 2011?
Offer a terse response. 0.62. What is the ratio of the Payments (BoP, current US$) of South Asia in 2007 to that in 2011?
Offer a very short reply. 0.54. What is the ratio of the Payments (BoP, current US$) in Algeria in 2007 to that in 2011?
Your response must be concise. 0.59. What is the ratio of the Payments (BoP, current US$) in Spain in 2007 to that in 2011?
Ensure brevity in your answer.  1.09. What is the ratio of the Payments (BoP, current US$) in Low & middle income in 2007 to that in 2012?
Provide a succinct answer. 0.59. What is the ratio of the Payments (BoP, current US$) of South Asia in 2007 to that in 2012?
Offer a very short reply. 0.51. What is the ratio of the Payments (BoP, current US$) of Algeria in 2007 to that in 2012?
Keep it short and to the point. 0.56. What is the ratio of the Payments (BoP, current US$) in Spain in 2007 to that in 2012?
Ensure brevity in your answer.  1.23. What is the ratio of the Payments (BoP, current US$) of Low & middle income in 2007 to that in 2013?
Ensure brevity in your answer.  0.56. What is the ratio of the Payments (BoP, current US$) of South Asia in 2007 to that in 2013?
Offer a terse response. 0.52. What is the ratio of the Payments (BoP, current US$) in Algeria in 2007 to that in 2013?
Make the answer very short. 0.53. What is the ratio of the Payments (BoP, current US$) in Spain in 2007 to that in 2013?
Your answer should be very brief. 1.31. What is the ratio of the Payments (BoP, current US$) of Low & middle income in 2008 to that in 2009?
Your response must be concise. 1.19. What is the ratio of the Payments (BoP, current US$) of South Asia in 2008 to that in 2009?
Your answer should be compact. 1.16. What is the ratio of the Payments (BoP, current US$) of Algeria in 2008 to that in 2009?
Provide a short and direct response. 1.01. What is the ratio of the Payments (BoP, current US$) in Spain in 2008 to that in 2009?
Keep it short and to the point. 1.36. What is the ratio of the Payments (BoP, current US$) of Low & middle income in 2008 to that in 2010?
Your response must be concise. 0.93. What is the ratio of the Payments (BoP, current US$) in South Asia in 2008 to that in 2010?
Give a very brief answer. 0.88. What is the ratio of the Payments (BoP, current US$) in Algeria in 2008 to that in 2010?
Provide a succinct answer. 1. What is the ratio of the Payments (BoP, current US$) of Spain in 2008 to that in 2010?
Offer a terse response. 1.3. What is the ratio of the Payments (BoP, current US$) in Low & middle income in 2008 to that in 2011?
Provide a short and direct response. 0.76. What is the ratio of the Payments (BoP, current US$) in South Asia in 2008 to that in 2011?
Give a very brief answer. 0.71. What is the ratio of the Payments (BoP, current US$) in Algeria in 2008 to that in 2011?
Offer a terse response. 0.84. What is the ratio of the Payments (BoP, current US$) of Spain in 2008 to that in 2011?
Offer a terse response. 1.16. What is the ratio of the Payments (BoP, current US$) of Low & middle income in 2008 to that in 2012?
Your answer should be compact. 0.72. What is the ratio of the Payments (BoP, current US$) of South Asia in 2008 to that in 2012?
Give a very brief answer. 0.68. What is the ratio of the Payments (BoP, current US$) in Algeria in 2008 to that in 2012?
Give a very brief answer. 0.79. What is the ratio of the Payments (BoP, current US$) in Spain in 2008 to that in 2012?
Give a very brief answer. 1.31. What is the ratio of the Payments (BoP, current US$) of Low & middle income in 2008 to that in 2013?
Provide a short and direct response. 0.68. What is the ratio of the Payments (BoP, current US$) of South Asia in 2008 to that in 2013?
Provide a succinct answer. 0.69. What is the ratio of the Payments (BoP, current US$) in Algeria in 2008 to that in 2013?
Ensure brevity in your answer.  0.75. What is the ratio of the Payments (BoP, current US$) of Spain in 2008 to that in 2013?
Your response must be concise. 1.39. What is the ratio of the Payments (BoP, current US$) in Low & middle income in 2009 to that in 2010?
Keep it short and to the point. 0.78. What is the ratio of the Payments (BoP, current US$) of South Asia in 2009 to that in 2010?
Your answer should be very brief. 0.76. What is the ratio of the Payments (BoP, current US$) of Algeria in 2009 to that in 2010?
Ensure brevity in your answer.  0.99. What is the ratio of the Payments (BoP, current US$) of Spain in 2009 to that in 2010?
Give a very brief answer. 0.96. What is the ratio of the Payments (BoP, current US$) of Low & middle income in 2009 to that in 2011?
Offer a terse response. 0.64. What is the ratio of the Payments (BoP, current US$) in South Asia in 2009 to that in 2011?
Provide a short and direct response. 0.62. What is the ratio of the Payments (BoP, current US$) of Algeria in 2009 to that in 2011?
Provide a succinct answer. 0.84. What is the ratio of the Payments (BoP, current US$) in Spain in 2009 to that in 2011?
Make the answer very short. 0.85. What is the ratio of the Payments (BoP, current US$) of Low & middle income in 2009 to that in 2012?
Your response must be concise. 0.6. What is the ratio of the Payments (BoP, current US$) of South Asia in 2009 to that in 2012?
Provide a succinct answer. 0.59. What is the ratio of the Payments (BoP, current US$) in Algeria in 2009 to that in 2012?
Offer a very short reply. 0.79. What is the ratio of the Payments (BoP, current US$) in Spain in 2009 to that in 2012?
Provide a succinct answer. 0.96. What is the ratio of the Payments (BoP, current US$) of Low & middle income in 2009 to that in 2013?
Keep it short and to the point. 0.57. What is the ratio of the Payments (BoP, current US$) in South Asia in 2009 to that in 2013?
Your answer should be compact. 0.59. What is the ratio of the Payments (BoP, current US$) of Algeria in 2009 to that in 2013?
Ensure brevity in your answer.  0.75. What is the ratio of the Payments (BoP, current US$) in Spain in 2009 to that in 2013?
Keep it short and to the point. 1.02. What is the ratio of the Payments (BoP, current US$) of Low & middle income in 2010 to that in 2011?
Make the answer very short. 0.81. What is the ratio of the Payments (BoP, current US$) of South Asia in 2010 to that in 2011?
Your answer should be very brief. 0.81. What is the ratio of the Payments (BoP, current US$) in Algeria in 2010 to that in 2011?
Your response must be concise. 0.84. What is the ratio of the Payments (BoP, current US$) of Spain in 2010 to that in 2011?
Provide a short and direct response. 0.89. What is the ratio of the Payments (BoP, current US$) in Low & middle income in 2010 to that in 2012?
Your response must be concise. 0.77. What is the ratio of the Payments (BoP, current US$) of South Asia in 2010 to that in 2012?
Your response must be concise. 0.77. What is the ratio of the Payments (BoP, current US$) in Algeria in 2010 to that in 2012?
Your response must be concise. 0.79. What is the ratio of the Payments (BoP, current US$) of Spain in 2010 to that in 2012?
Offer a terse response. 1.01. What is the ratio of the Payments (BoP, current US$) of Low & middle income in 2010 to that in 2013?
Offer a very short reply. 0.73. What is the ratio of the Payments (BoP, current US$) in South Asia in 2010 to that in 2013?
Provide a short and direct response. 0.78. What is the ratio of the Payments (BoP, current US$) in Algeria in 2010 to that in 2013?
Offer a very short reply. 0.75. What is the ratio of the Payments (BoP, current US$) of Spain in 2010 to that in 2013?
Your answer should be compact. 1.07. What is the ratio of the Payments (BoP, current US$) in Low & middle income in 2011 to that in 2012?
Offer a terse response. 0.95. What is the ratio of the Payments (BoP, current US$) in South Asia in 2011 to that in 2012?
Make the answer very short. 0.95. What is the ratio of the Payments (BoP, current US$) in Algeria in 2011 to that in 2012?
Ensure brevity in your answer.  0.94. What is the ratio of the Payments (BoP, current US$) in Spain in 2011 to that in 2012?
Give a very brief answer. 1.13. What is the ratio of the Payments (BoP, current US$) of Low & middle income in 2011 to that in 2013?
Ensure brevity in your answer.  0.9. What is the ratio of the Payments (BoP, current US$) in South Asia in 2011 to that in 2013?
Make the answer very short. 0.97. What is the ratio of the Payments (BoP, current US$) of Algeria in 2011 to that in 2013?
Provide a short and direct response. 0.89. What is the ratio of the Payments (BoP, current US$) of Spain in 2011 to that in 2013?
Your response must be concise. 1.2. What is the ratio of the Payments (BoP, current US$) in Low & middle income in 2012 to that in 2013?
Make the answer very short. 0.95. What is the ratio of the Payments (BoP, current US$) of South Asia in 2012 to that in 2013?
Your answer should be very brief. 1.02. What is the ratio of the Payments (BoP, current US$) in Algeria in 2012 to that in 2013?
Keep it short and to the point. 0.95. What is the ratio of the Payments (BoP, current US$) in Spain in 2012 to that in 2013?
Your response must be concise. 1.06. What is the difference between the highest and the second highest Payments (BoP, current US$) of Low & middle income?
Your answer should be very brief. 3.62e+11. What is the difference between the highest and the second highest Payments (BoP, current US$) of South Asia?
Your answer should be compact. 1.15e+1. What is the difference between the highest and the second highest Payments (BoP, current US$) of Algeria?
Your answer should be compact. 3.55e+09. What is the difference between the highest and the second highest Payments (BoP, current US$) in Spain?
Make the answer very short. 3.99e+1. What is the difference between the highest and the lowest Payments (BoP, current US$) in Low & middle income?
Offer a terse response. 3.26e+12. What is the difference between the highest and the lowest Payments (BoP, current US$) in South Asia?
Give a very brief answer. 3.65e+11. What is the difference between the highest and the lowest Payments (BoP, current US$) in Algeria?
Your answer should be very brief. 3.47e+1. What is the difference between the highest and the lowest Payments (BoP, current US$) of Spain?
Offer a very short reply. 1.81e+11. 